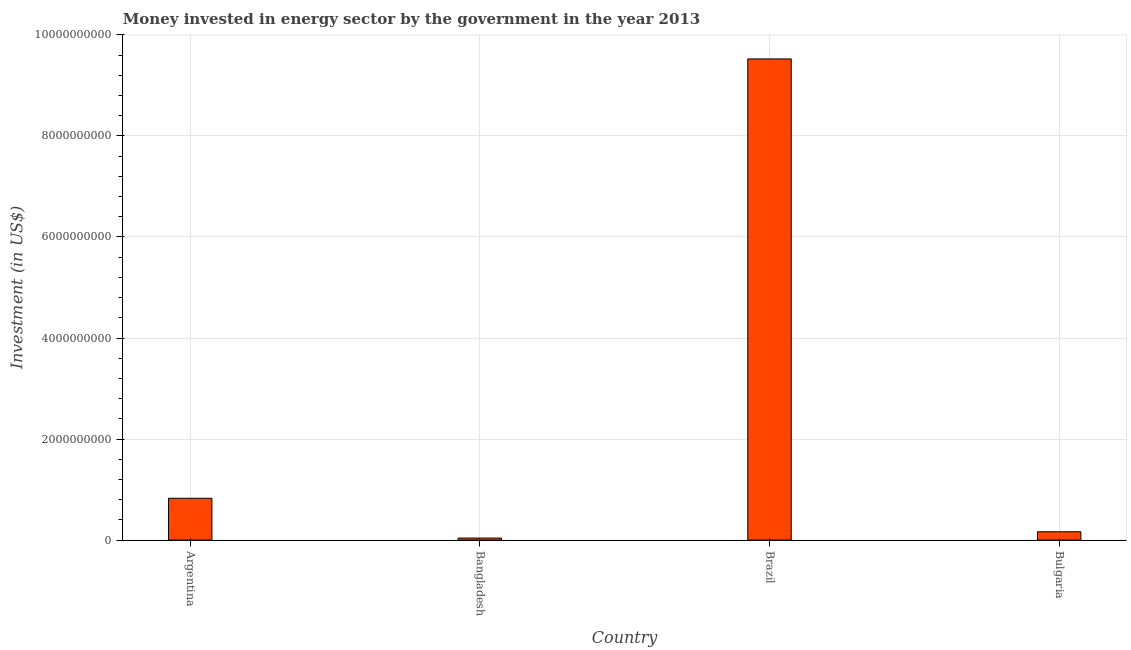Does the graph contain grids?
Your answer should be compact. Yes. What is the title of the graph?
Offer a very short reply. Money invested in energy sector by the government in the year 2013. What is the label or title of the Y-axis?
Provide a succinct answer. Investment (in US$). What is the investment in energy in Bangladesh?
Offer a terse response. 4.03e+07. Across all countries, what is the maximum investment in energy?
Offer a terse response. 9.52e+09. Across all countries, what is the minimum investment in energy?
Provide a short and direct response. 4.03e+07. What is the sum of the investment in energy?
Provide a short and direct response. 1.06e+1. What is the difference between the investment in energy in Argentina and Brazil?
Give a very brief answer. -8.70e+09. What is the average investment in energy per country?
Your response must be concise. 2.64e+09. What is the median investment in energy?
Offer a terse response. 4.96e+08. What is the ratio of the investment in energy in Argentina to that in Brazil?
Make the answer very short. 0.09. Is the investment in energy in Brazil less than that in Bulgaria?
Provide a short and direct response. No. Is the difference between the investment in energy in Argentina and Brazil greater than the difference between any two countries?
Ensure brevity in your answer.  No. What is the difference between the highest and the second highest investment in energy?
Make the answer very short. 8.70e+09. Is the sum of the investment in energy in Bangladesh and Brazil greater than the maximum investment in energy across all countries?
Provide a succinct answer. Yes. What is the difference between the highest and the lowest investment in energy?
Your answer should be very brief. 9.48e+09. In how many countries, is the investment in energy greater than the average investment in energy taken over all countries?
Your answer should be compact. 1. How many bars are there?
Your answer should be compact. 4. Are all the bars in the graph horizontal?
Give a very brief answer. No. What is the difference between two consecutive major ticks on the Y-axis?
Provide a succinct answer. 2.00e+09. What is the Investment (in US$) of Argentina?
Give a very brief answer. 8.28e+08. What is the Investment (in US$) of Bangladesh?
Your answer should be compact. 4.03e+07. What is the Investment (in US$) of Brazil?
Your answer should be very brief. 9.52e+09. What is the Investment (in US$) of Bulgaria?
Offer a very short reply. 1.65e+08. What is the difference between the Investment (in US$) in Argentina and Bangladesh?
Provide a short and direct response. 7.88e+08. What is the difference between the Investment (in US$) in Argentina and Brazil?
Offer a very short reply. -8.70e+09. What is the difference between the Investment (in US$) in Argentina and Bulgaria?
Offer a very short reply. 6.63e+08. What is the difference between the Investment (in US$) in Bangladesh and Brazil?
Your response must be concise. -9.48e+09. What is the difference between the Investment (in US$) in Bangladesh and Bulgaria?
Offer a terse response. -1.25e+08. What is the difference between the Investment (in US$) in Brazil and Bulgaria?
Make the answer very short. 9.36e+09. What is the ratio of the Investment (in US$) in Argentina to that in Bangladesh?
Your answer should be compact. 20.55. What is the ratio of the Investment (in US$) in Argentina to that in Brazil?
Provide a short and direct response. 0.09. What is the ratio of the Investment (in US$) in Argentina to that in Bulgaria?
Keep it short and to the point. 5.02. What is the ratio of the Investment (in US$) in Bangladesh to that in Brazil?
Give a very brief answer. 0. What is the ratio of the Investment (in US$) in Bangladesh to that in Bulgaria?
Provide a succinct answer. 0.24. What is the ratio of the Investment (in US$) in Brazil to that in Bulgaria?
Give a very brief answer. 57.73. 